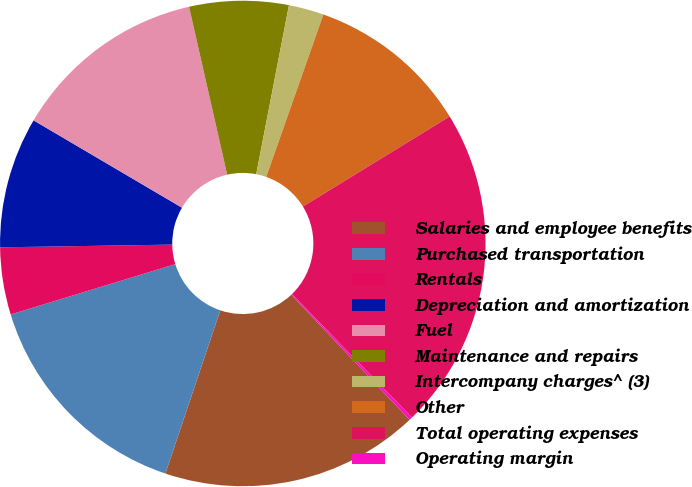Convert chart to OTSL. <chart><loc_0><loc_0><loc_500><loc_500><pie_chart><fcel>Salaries and employee benefits<fcel>Purchased transportation<fcel>Rentals<fcel>Depreciation and amortization<fcel>Fuel<fcel>Maintenance and repairs<fcel>Intercompany charges^ (3)<fcel>Other<fcel>Total operating expenses<fcel>Operating margin<nl><fcel>17.23%<fcel>15.11%<fcel>4.47%<fcel>8.72%<fcel>12.98%<fcel>6.6%<fcel>2.34%<fcel>10.85%<fcel>21.49%<fcel>0.21%<nl></chart> 